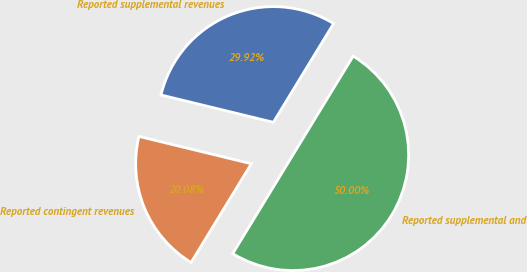Convert chart to OTSL. <chart><loc_0><loc_0><loc_500><loc_500><pie_chart><fcel>Reported supplemental revenues<fcel>Reported contingent revenues<fcel>Reported supplemental and<nl><fcel>29.92%<fcel>20.08%<fcel>50.0%<nl></chart> 